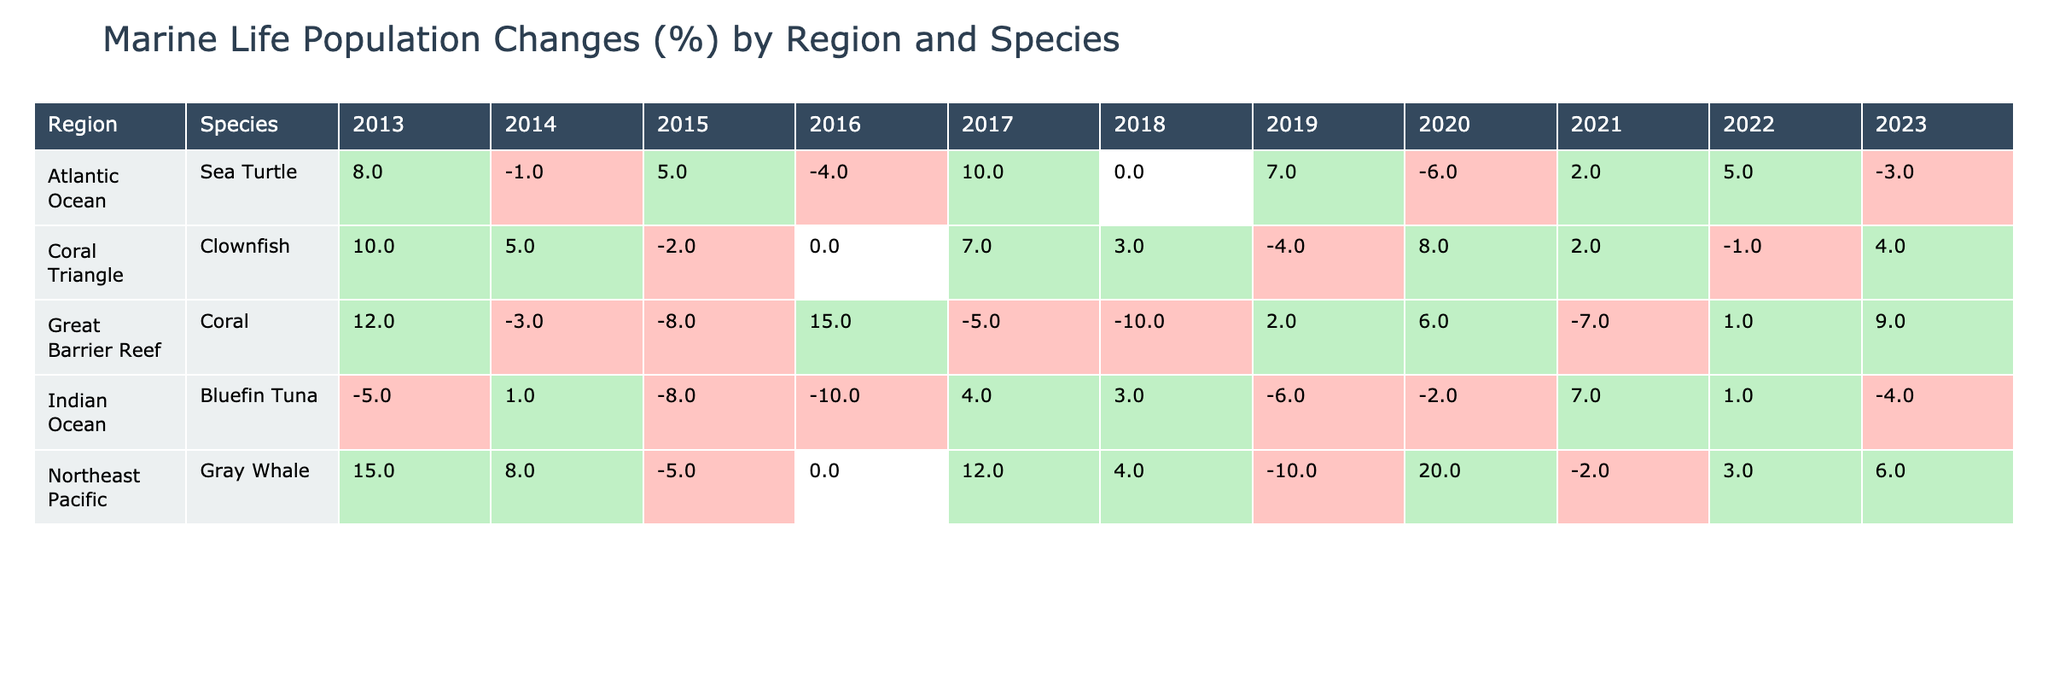What was the population change of Clownfish in the Coral Triangle in 2018? The table shows that in 2018, the population change of Clownfish in the Coral Triangle was 3%.
Answer: 3% Which species in the Great Barrier Reef had the highest negative population change and in which year? From the table, Corals showed the highest negative population change of -10% in the year 2018.
Answer: Coral, 2018 What is the overall population change for Gray Whales over the decade? By adding the population changes: 15 + 8 - 5 + 0 + 12 + 4 - 10 + 20 - 2 + 3 + 6 = 57%, so the overall change is 57%.
Answer: 57% In which year did the population of Sea Turtles show the highest percentage increase? The table indicates that in 2017, the Sea Turtles had a population increase of 10%, which is the highest for any single year.
Answer: 2017 Has the population of Bluefin Tuna shown a consistent positive change over the last decade? Reviewing the data reveals that Bluefin Tuna has fluctuated, with both increases and significant decreases, indicating inconsistency in population changes.
Answer: No What is the average change in population percentage for Clownfish from 2013 to 2023? Adding the population changes: 10 + 5 - 2 + 0 + 7 + 3 - 4 + 8 + 2 - 1 + 4 = 28%. There are 11 years, so the average is 28/11 ≈ 2.55%.
Answer: ≈ 2.55% In what year did the population of Gray Whales experience a decline greater than 5%? The table shows declines of -5% in 2015 and -10% in 2019, which are both greater than 5%.
Answer: 2015, 2019 What was the trend in population change for Coral in the Great Barrier Reef from 2013 to 2023? Analyzing the years shows fluctuations with both increases and significant declines; overall trends show inconsistent population changes throughout the decade.
Answer: Inconsistent Which region and species had the most significant population improvement in 2020? In 2020, the Gray Whale in the Northeast Pacific experienced a significant improvement of 20%, the highest noted for that year.
Answer: Northeast Pacific, Gray Whale What are the conservation statuses of species in the Atlantic Ocean? Looking at the table, all species in the Atlantic Ocean (Sea Turtle) are classified as Vulnerable or Endangered throughout the years.
Answer: Vulnerable, Endangered 